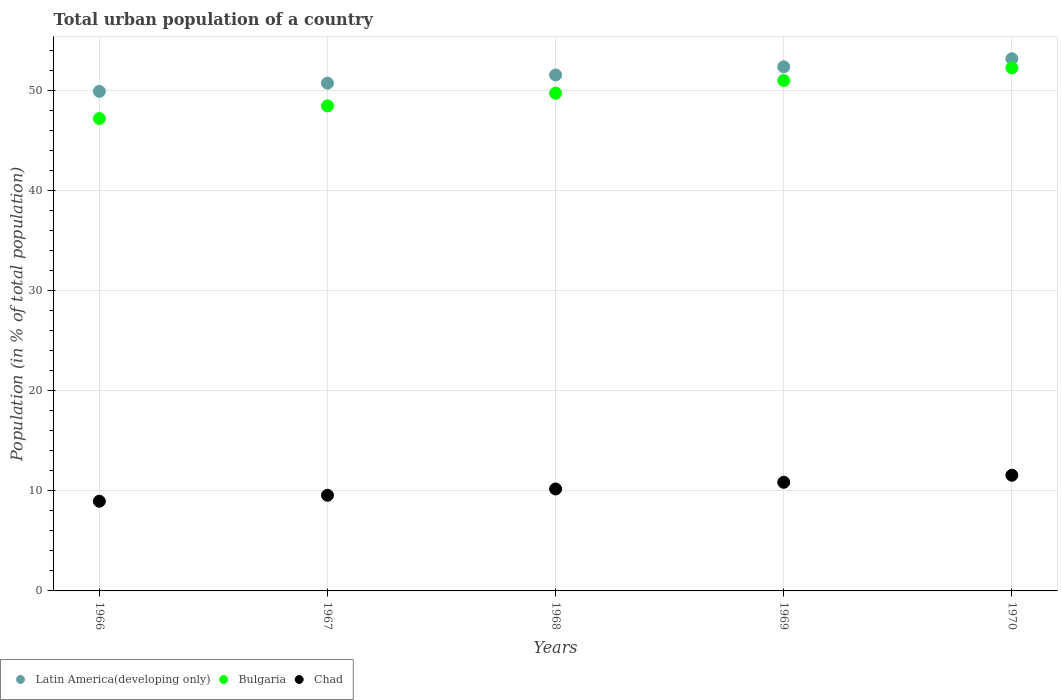How many different coloured dotlines are there?
Offer a terse response. 3. What is the urban population in Chad in 1969?
Your answer should be compact. 10.86. Across all years, what is the maximum urban population in Bulgaria?
Offer a very short reply. 52.3. Across all years, what is the minimum urban population in Bulgaria?
Provide a succinct answer. 47.23. In which year was the urban population in Bulgaria minimum?
Ensure brevity in your answer.  1966. What is the total urban population in Latin America(developing only) in the graph?
Offer a terse response. 257.94. What is the difference between the urban population in Latin America(developing only) in 1966 and that in 1969?
Give a very brief answer. -2.45. What is the difference between the urban population in Chad in 1969 and the urban population in Bulgaria in 1968?
Make the answer very short. -38.91. What is the average urban population in Bulgaria per year?
Offer a terse response. 49.77. In the year 1970, what is the difference between the urban population in Latin America(developing only) and urban population in Chad?
Your response must be concise. 41.65. What is the ratio of the urban population in Bulgaria in 1967 to that in 1970?
Keep it short and to the point. 0.93. Is the urban population in Latin America(developing only) in 1966 less than that in 1969?
Make the answer very short. Yes. Is the difference between the urban population in Latin America(developing only) in 1967 and 1969 greater than the difference between the urban population in Chad in 1967 and 1969?
Your answer should be compact. No. What is the difference between the highest and the second highest urban population in Chad?
Give a very brief answer. 0.71. What is the difference between the highest and the lowest urban population in Latin America(developing only)?
Offer a terse response. 3.26. Is the sum of the urban population in Latin America(developing only) in 1967 and 1969 greater than the maximum urban population in Chad across all years?
Give a very brief answer. Yes. Does the urban population in Chad monotonically increase over the years?
Offer a terse response. Yes. How many dotlines are there?
Your response must be concise. 3. How many years are there in the graph?
Keep it short and to the point. 5. What is the difference between two consecutive major ticks on the Y-axis?
Your answer should be very brief. 10. Does the graph contain any zero values?
Keep it short and to the point. No. Does the graph contain grids?
Your response must be concise. Yes. What is the title of the graph?
Provide a succinct answer. Total urban population of a country. Does "Tajikistan" appear as one of the legend labels in the graph?
Offer a terse response. No. What is the label or title of the Y-axis?
Offer a terse response. Population (in % of total population). What is the Population (in % of total population) of Latin America(developing only) in 1966?
Ensure brevity in your answer.  49.95. What is the Population (in % of total population) in Bulgaria in 1966?
Your answer should be compact. 47.23. What is the Population (in % of total population) in Chad in 1966?
Your answer should be very brief. 8.97. What is the Population (in % of total population) in Latin America(developing only) in 1967?
Provide a short and direct response. 50.77. What is the Population (in % of total population) in Bulgaria in 1967?
Provide a succinct answer. 48.5. What is the Population (in % of total population) in Chad in 1967?
Provide a succinct answer. 9.56. What is the Population (in % of total population) of Latin America(developing only) in 1968?
Give a very brief answer. 51.59. What is the Population (in % of total population) in Bulgaria in 1968?
Provide a short and direct response. 49.77. What is the Population (in % of total population) of Chad in 1968?
Your answer should be very brief. 10.2. What is the Population (in % of total population) in Latin America(developing only) in 1969?
Your response must be concise. 52.41. What is the Population (in % of total population) of Bulgaria in 1969?
Give a very brief answer. 51.03. What is the Population (in % of total population) in Chad in 1969?
Ensure brevity in your answer.  10.86. What is the Population (in % of total population) in Latin America(developing only) in 1970?
Your response must be concise. 53.22. What is the Population (in % of total population) of Bulgaria in 1970?
Your response must be concise. 52.3. What is the Population (in % of total population) in Chad in 1970?
Your answer should be compact. 11.57. Across all years, what is the maximum Population (in % of total population) in Latin America(developing only)?
Ensure brevity in your answer.  53.22. Across all years, what is the maximum Population (in % of total population) of Bulgaria?
Keep it short and to the point. 52.3. Across all years, what is the maximum Population (in % of total population) in Chad?
Provide a succinct answer. 11.57. Across all years, what is the minimum Population (in % of total population) of Latin America(developing only)?
Your answer should be very brief. 49.95. Across all years, what is the minimum Population (in % of total population) of Bulgaria?
Provide a succinct answer. 47.23. Across all years, what is the minimum Population (in % of total population) in Chad?
Your answer should be compact. 8.97. What is the total Population (in % of total population) in Latin America(developing only) in the graph?
Provide a short and direct response. 257.94. What is the total Population (in % of total population) of Bulgaria in the graph?
Your response must be concise. 248.83. What is the total Population (in % of total population) of Chad in the graph?
Give a very brief answer. 51.16. What is the difference between the Population (in % of total population) in Latin America(developing only) in 1966 and that in 1967?
Your answer should be compact. -0.82. What is the difference between the Population (in % of total population) of Bulgaria in 1966 and that in 1967?
Provide a short and direct response. -1.27. What is the difference between the Population (in % of total population) of Chad in 1966 and that in 1967?
Your answer should be compact. -0.6. What is the difference between the Population (in % of total population) in Latin America(developing only) in 1966 and that in 1968?
Offer a terse response. -1.64. What is the difference between the Population (in % of total population) of Bulgaria in 1966 and that in 1968?
Ensure brevity in your answer.  -2.54. What is the difference between the Population (in % of total population) of Chad in 1966 and that in 1968?
Ensure brevity in your answer.  -1.23. What is the difference between the Population (in % of total population) of Latin America(developing only) in 1966 and that in 1969?
Give a very brief answer. -2.45. What is the difference between the Population (in % of total population) of Bulgaria in 1966 and that in 1969?
Offer a terse response. -3.8. What is the difference between the Population (in % of total population) of Chad in 1966 and that in 1969?
Your response must be concise. -1.89. What is the difference between the Population (in % of total population) in Latin America(developing only) in 1966 and that in 1970?
Ensure brevity in your answer.  -3.26. What is the difference between the Population (in % of total population) in Bulgaria in 1966 and that in 1970?
Provide a short and direct response. -5.07. What is the difference between the Population (in % of total population) of Latin America(developing only) in 1967 and that in 1968?
Keep it short and to the point. -0.82. What is the difference between the Population (in % of total population) in Bulgaria in 1967 and that in 1968?
Your response must be concise. -1.27. What is the difference between the Population (in % of total population) in Chad in 1967 and that in 1968?
Make the answer very short. -0.63. What is the difference between the Population (in % of total population) in Latin America(developing only) in 1967 and that in 1969?
Provide a short and direct response. -1.64. What is the difference between the Population (in % of total population) in Bulgaria in 1967 and that in 1969?
Provide a succinct answer. -2.54. What is the difference between the Population (in % of total population) of Chad in 1967 and that in 1969?
Make the answer very short. -1.3. What is the difference between the Population (in % of total population) of Latin America(developing only) in 1967 and that in 1970?
Provide a short and direct response. -2.45. What is the difference between the Population (in % of total population) of Bulgaria in 1967 and that in 1970?
Ensure brevity in your answer.  -3.8. What is the difference between the Population (in % of total population) of Chad in 1967 and that in 1970?
Give a very brief answer. -2. What is the difference between the Population (in % of total population) of Latin America(developing only) in 1968 and that in 1969?
Your response must be concise. -0.82. What is the difference between the Population (in % of total population) of Bulgaria in 1968 and that in 1969?
Your answer should be very brief. -1.27. What is the difference between the Population (in % of total population) in Chad in 1968 and that in 1969?
Make the answer very short. -0.67. What is the difference between the Population (in % of total population) in Latin America(developing only) in 1968 and that in 1970?
Offer a very short reply. -1.63. What is the difference between the Population (in % of total population) in Bulgaria in 1968 and that in 1970?
Your response must be concise. -2.53. What is the difference between the Population (in % of total population) of Chad in 1968 and that in 1970?
Your answer should be compact. -1.37. What is the difference between the Population (in % of total population) in Latin America(developing only) in 1969 and that in 1970?
Ensure brevity in your answer.  -0.81. What is the difference between the Population (in % of total population) in Bulgaria in 1969 and that in 1970?
Keep it short and to the point. -1.27. What is the difference between the Population (in % of total population) of Chad in 1969 and that in 1970?
Provide a short and direct response. -0.71. What is the difference between the Population (in % of total population) of Latin America(developing only) in 1966 and the Population (in % of total population) of Bulgaria in 1967?
Provide a succinct answer. 1.45. What is the difference between the Population (in % of total population) in Latin America(developing only) in 1966 and the Population (in % of total population) in Chad in 1967?
Provide a short and direct response. 40.39. What is the difference between the Population (in % of total population) of Bulgaria in 1966 and the Population (in % of total population) of Chad in 1967?
Offer a terse response. 37.67. What is the difference between the Population (in % of total population) of Latin America(developing only) in 1966 and the Population (in % of total population) of Bulgaria in 1968?
Offer a terse response. 0.18. What is the difference between the Population (in % of total population) of Latin America(developing only) in 1966 and the Population (in % of total population) of Chad in 1968?
Give a very brief answer. 39.76. What is the difference between the Population (in % of total population) of Bulgaria in 1966 and the Population (in % of total population) of Chad in 1968?
Your answer should be compact. 37.04. What is the difference between the Population (in % of total population) of Latin America(developing only) in 1966 and the Population (in % of total population) of Bulgaria in 1969?
Provide a succinct answer. -1.08. What is the difference between the Population (in % of total population) of Latin America(developing only) in 1966 and the Population (in % of total population) of Chad in 1969?
Keep it short and to the point. 39.09. What is the difference between the Population (in % of total population) in Bulgaria in 1966 and the Population (in % of total population) in Chad in 1969?
Provide a short and direct response. 36.37. What is the difference between the Population (in % of total population) in Latin America(developing only) in 1966 and the Population (in % of total population) in Bulgaria in 1970?
Make the answer very short. -2.35. What is the difference between the Population (in % of total population) in Latin America(developing only) in 1966 and the Population (in % of total population) in Chad in 1970?
Ensure brevity in your answer.  38.38. What is the difference between the Population (in % of total population) of Bulgaria in 1966 and the Population (in % of total population) of Chad in 1970?
Offer a terse response. 35.66. What is the difference between the Population (in % of total population) of Latin America(developing only) in 1967 and the Population (in % of total population) of Chad in 1968?
Provide a succinct answer. 40.58. What is the difference between the Population (in % of total population) in Bulgaria in 1967 and the Population (in % of total population) in Chad in 1968?
Keep it short and to the point. 38.3. What is the difference between the Population (in % of total population) of Latin America(developing only) in 1967 and the Population (in % of total population) of Bulgaria in 1969?
Your response must be concise. -0.26. What is the difference between the Population (in % of total population) of Latin America(developing only) in 1967 and the Population (in % of total population) of Chad in 1969?
Provide a succinct answer. 39.91. What is the difference between the Population (in % of total population) in Bulgaria in 1967 and the Population (in % of total population) in Chad in 1969?
Your answer should be very brief. 37.64. What is the difference between the Population (in % of total population) of Latin America(developing only) in 1967 and the Population (in % of total population) of Bulgaria in 1970?
Provide a short and direct response. -1.53. What is the difference between the Population (in % of total population) in Latin America(developing only) in 1967 and the Population (in % of total population) in Chad in 1970?
Provide a succinct answer. 39.2. What is the difference between the Population (in % of total population) of Bulgaria in 1967 and the Population (in % of total population) of Chad in 1970?
Provide a succinct answer. 36.93. What is the difference between the Population (in % of total population) in Latin America(developing only) in 1968 and the Population (in % of total population) in Bulgaria in 1969?
Provide a succinct answer. 0.56. What is the difference between the Population (in % of total population) in Latin America(developing only) in 1968 and the Population (in % of total population) in Chad in 1969?
Ensure brevity in your answer.  40.73. What is the difference between the Population (in % of total population) in Bulgaria in 1968 and the Population (in % of total population) in Chad in 1969?
Give a very brief answer. 38.91. What is the difference between the Population (in % of total population) of Latin America(developing only) in 1968 and the Population (in % of total population) of Bulgaria in 1970?
Offer a terse response. -0.71. What is the difference between the Population (in % of total population) in Latin America(developing only) in 1968 and the Population (in % of total population) in Chad in 1970?
Your answer should be very brief. 40.02. What is the difference between the Population (in % of total population) in Bulgaria in 1968 and the Population (in % of total population) in Chad in 1970?
Keep it short and to the point. 38.2. What is the difference between the Population (in % of total population) of Latin America(developing only) in 1969 and the Population (in % of total population) of Bulgaria in 1970?
Give a very brief answer. 0.11. What is the difference between the Population (in % of total population) in Latin America(developing only) in 1969 and the Population (in % of total population) in Chad in 1970?
Offer a very short reply. 40.84. What is the difference between the Population (in % of total population) in Bulgaria in 1969 and the Population (in % of total population) in Chad in 1970?
Offer a terse response. 39.47. What is the average Population (in % of total population) of Latin America(developing only) per year?
Offer a very short reply. 51.59. What is the average Population (in % of total population) of Bulgaria per year?
Provide a succinct answer. 49.77. What is the average Population (in % of total population) in Chad per year?
Offer a terse response. 10.23. In the year 1966, what is the difference between the Population (in % of total population) in Latin America(developing only) and Population (in % of total population) in Bulgaria?
Offer a terse response. 2.72. In the year 1966, what is the difference between the Population (in % of total population) of Latin America(developing only) and Population (in % of total population) of Chad?
Offer a very short reply. 40.98. In the year 1966, what is the difference between the Population (in % of total population) in Bulgaria and Population (in % of total population) in Chad?
Keep it short and to the point. 38.27. In the year 1967, what is the difference between the Population (in % of total population) in Latin America(developing only) and Population (in % of total population) in Bulgaria?
Your answer should be compact. 2.27. In the year 1967, what is the difference between the Population (in % of total population) of Latin America(developing only) and Population (in % of total population) of Chad?
Provide a succinct answer. 41.21. In the year 1967, what is the difference between the Population (in % of total population) in Bulgaria and Population (in % of total population) in Chad?
Make the answer very short. 38.94. In the year 1968, what is the difference between the Population (in % of total population) of Latin America(developing only) and Population (in % of total population) of Bulgaria?
Make the answer very short. 1.82. In the year 1968, what is the difference between the Population (in % of total population) of Latin America(developing only) and Population (in % of total population) of Chad?
Keep it short and to the point. 41.39. In the year 1968, what is the difference between the Population (in % of total population) in Bulgaria and Population (in % of total population) in Chad?
Offer a very short reply. 39.57. In the year 1969, what is the difference between the Population (in % of total population) in Latin America(developing only) and Population (in % of total population) in Bulgaria?
Ensure brevity in your answer.  1.37. In the year 1969, what is the difference between the Population (in % of total population) of Latin America(developing only) and Population (in % of total population) of Chad?
Ensure brevity in your answer.  41.54. In the year 1969, what is the difference between the Population (in % of total population) in Bulgaria and Population (in % of total population) in Chad?
Provide a short and direct response. 40.17. In the year 1970, what is the difference between the Population (in % of total population) in Latin America(developing only) and Population (in % of total population) in Bulgaria?
Your answer should be compact. 0.92. In the year 1970, what is the difference between the Population (in % of total population) in Latin America(developing only) and Population (in % of total population) in Chad?
Your response must be concise. 41.65. In the year 1970, what is the difference between the Population (in % of total population) of Bulgaria and Population (in % of total population) of Chad?
Your answer should be compact. 40.73. What is the ratio of the Population (in % of total population) of Latin America(developing only) in 1966 to that in 1967?
Provide a succinct answer. 0.98. What is the ratio of the Population (in % of total population) in Bulgaria in 1966 to that in 1967?
Offer a very short reply. 0.97. What is the ratio of the Population (in % of total population) of Chad in 1966 to that in 1967?
Your response must be concise. 0.94. What is the ratio of the Population (in % of total population) in Latin America(developing only) in 1966 to that in 1968?
Make the answer very short. 0.97. What is the ratio of the Population (in % of total population) in Bulgaria in 1966 to that in 1968?
Provide a short and direct response. 0.95. What is the ratio of the Population (in % of total population) in Chad in 1966 to that in 1968?
Ensure brevity in your answer.  0.88. What is the ratio of the Population (in % of total population) of Latin America(developing only) in 1966 to that in 1969?
Give a very brief answer. 0.95. What is the ratio of the Population (in % of total population) of Bulgaria in 1966 to that in 1969?
Your response must be concise. 0.93. What is the ratio of the Population (in % of total population) in Chad in 1966 to that in 1969?
Ensure brevity in your answer.  0.83. What is the ratio of the Population (in % of total population) of Latin America(developing only) in 1966 to that in 1970?
Make the answer very short. 0.94. What is the ratio of the Population (in % of total population) of Bulgaria in 1966 to that in 1970?
Your answer should be compact. 0.9. What is the ratio of the Population (in % of total population) in Chad in 1966 to that in 1970?
Give a very brief answer. 0.78. What is the ratio of the Population (in % of total population) of Latin America(developing only) in 1967 to that in 1968?
Your answer should be very brief. 0.98. What is the ratio of the Population (in % of total population) of Bulgaria in 1967 to that in 1968?
Give a very brief answer. 0.97. What is the ratio of the Population (in % of total population) in Chad in 1967 to that in 1968?
Make the answer very short. 0.94. What is the ratio of the Population (in % of total population) of Latin America(developing only) in 1967 to that in 1969?
Your answer should be compact. 0.97. What is the ratio of the Population (in % of total population) of Bulgaria in 1967 to that in 1969?
Offer a terse response. 0.95. What is the ratio of the Population (in % of total population) of Chad in 1967 to that in 1969?
Your answer should be compact. 0.88. What is the ratio of the Population (in % of total population) in Latin America(developing only) in 1967 to that in 1970?
Your answer should be very brief. 0.95. What is the ratio of the Population (in % of total population) of Bulgaria in 1967 to that in 1970?
Provide a short and direct response. 0.93. What is the ratio of the Population (in % of total population) in Chad in 1967 to that in 1970?
Your answer should be very brief. 0.83. What is the ratio of the Population (in % of total population) in Latin America(developing only) in 1968 to that in 1969?
Your answer should be compact. 0.98. What is the ratio of the Population (in % of total population) in Bulgaria in 1968 to that in 1969?
Your response must be concise. 0.98. What is the ratio of the Population (in % of total population) in Chad in 1968 to that in 1969?
Ensure brevity in your answer.  0.94. What is the ratio of the Population (in % of total population) of Latin America(developing only) in 1968 to that in 1970?
Offer a very short reply. 0.97. What is the ratio of the Population (in % of total population) of Bulgaria in 1968 to that in 1970?
Provide a succinct answer. 0.95. What is the ratio of the Population (in % of total population) of Chad in 1968 to that in 1970?
Provide a short and direct response. 0.88. What is the ratio of the Population (in % of total population) in Bulgaria in 1969 to that in 1970?
Provide a short and direct response. 0.98. What is the ratio of the Population (in % of total population) of Chad in 1969 to that in 1970?
Provide a succinct answer. 0.94. What is the difference between the highest and the second highest Population (in % of total population) in Latin America(developing only)?
Ensure brevity in your answer.  0.81. What is the difference between the highest and the second highest Population (in % of total population) in Bulgaria?
Provide a succinct answer. 1.27. What is the difference between the highest and the second highest Population (in % of total population) of Chad?
Your answer should be very brief. 0.71. What is the difference between the highest and the lowest Population (in % of total population) in Latin America(developing only)?
Your answer should be very brief. 3.26. What is the difference between the highest and the lowest Population (in % of total population) of Bulgaria?
Keep it short and to the point. 5.07. What is the difference between the highest and the lowest Population (in % of total population) of Chad?
Keep it short and to the point. 2.6. 